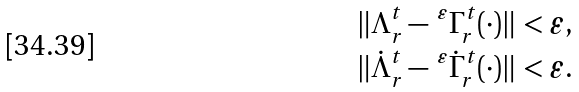<formula> <loc_0><loc_0><loc_500><loc_500>& \| \Lambda ^ { t } _ { r } - \, ^ { \varepsilon } \Gamma ^ { t } _ { r } ( \cdot ) \| < \varepsilon , \\ & \| \dot { \Lambda } ^ { t } _ { r } - \, ^ { \varepsilon } \dot { \Gamma } ^ { t } _ { r } ( \cdot ) \| < \varepsilon .</formula> 